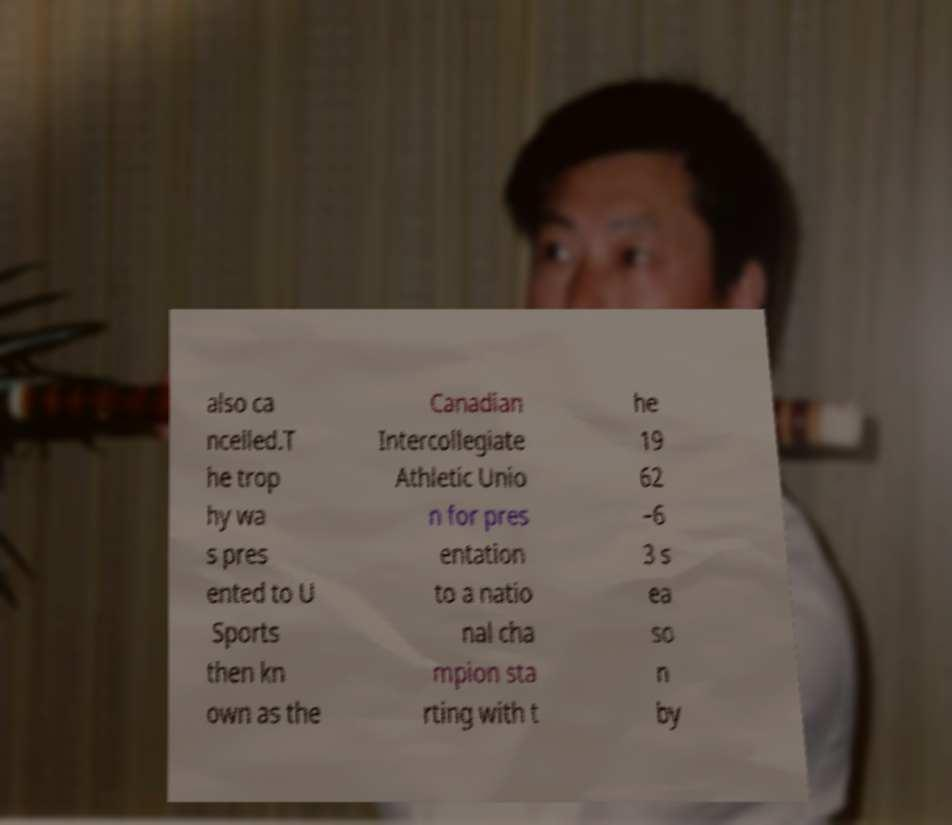For documentation purposes, I need the text within this image transcribed. Could you provide that? also ca ncelled.T he trop hy wa s pres ented to U Sports then kn own as the Canadian Intercollegiate Athletic Unio n for pres entation to a natio nal cha mpion sta rting with t he 19 62 –6 3 s ea so n by 